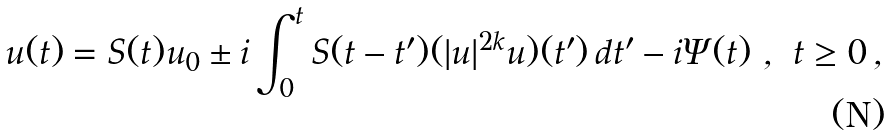Convert formula to latex. <formula><loc_0><loc_0><loc_500><loc_500>u ( t ) = S ( t ) u _ { 0 } \pm i \int _ { 0 } ^ { t } S ( t - t ^ { \prime } ) ( | u | ^ { 2 k } u ) ( t ^ { \prime } ) \, d t ^ { \prime } - i \Psi ( t ) \ , \ t \geq 0 \, ,</formula> 